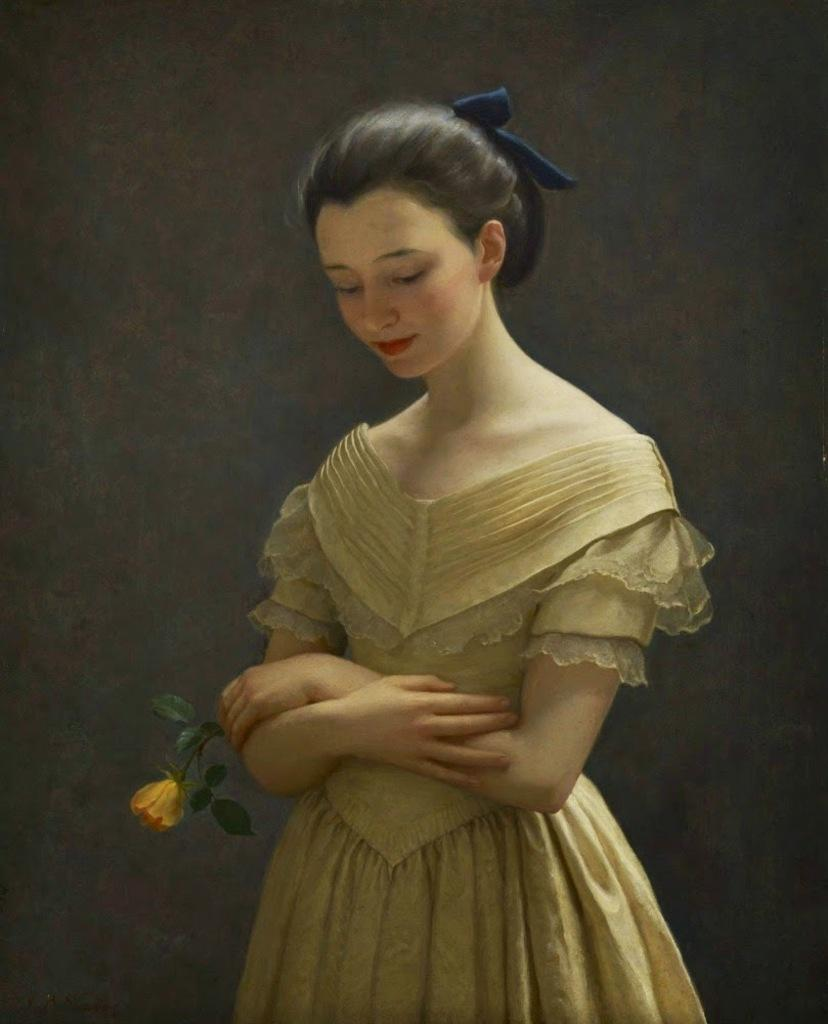What type of artwork is depicted in the image? The image is a painting. Can you describe the main subject of the painting? There is a woman in the center of the painting. What is the woman holding in the painting? The woman is holding a rose. What color is the background of the painting? The background of the painting is black. How many spiders are crawling on the woman's shoulder in the painting? There are no spiders present in the painting; the woman is holding a rose. What type of chalk is being used to draw the painting? The painting is not being drawn with chalk; it is a finished artwork. 